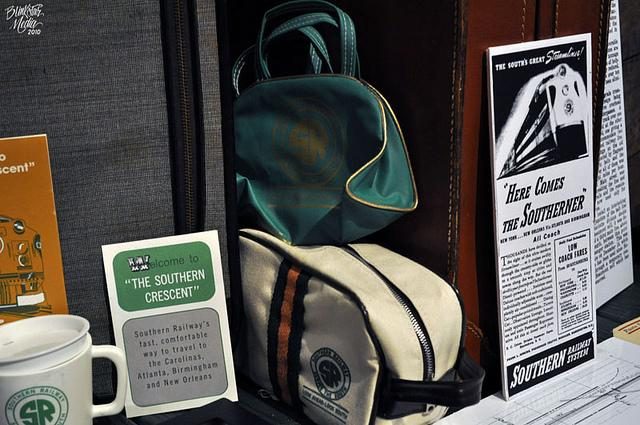What mode of transportation is The Southerner? train 